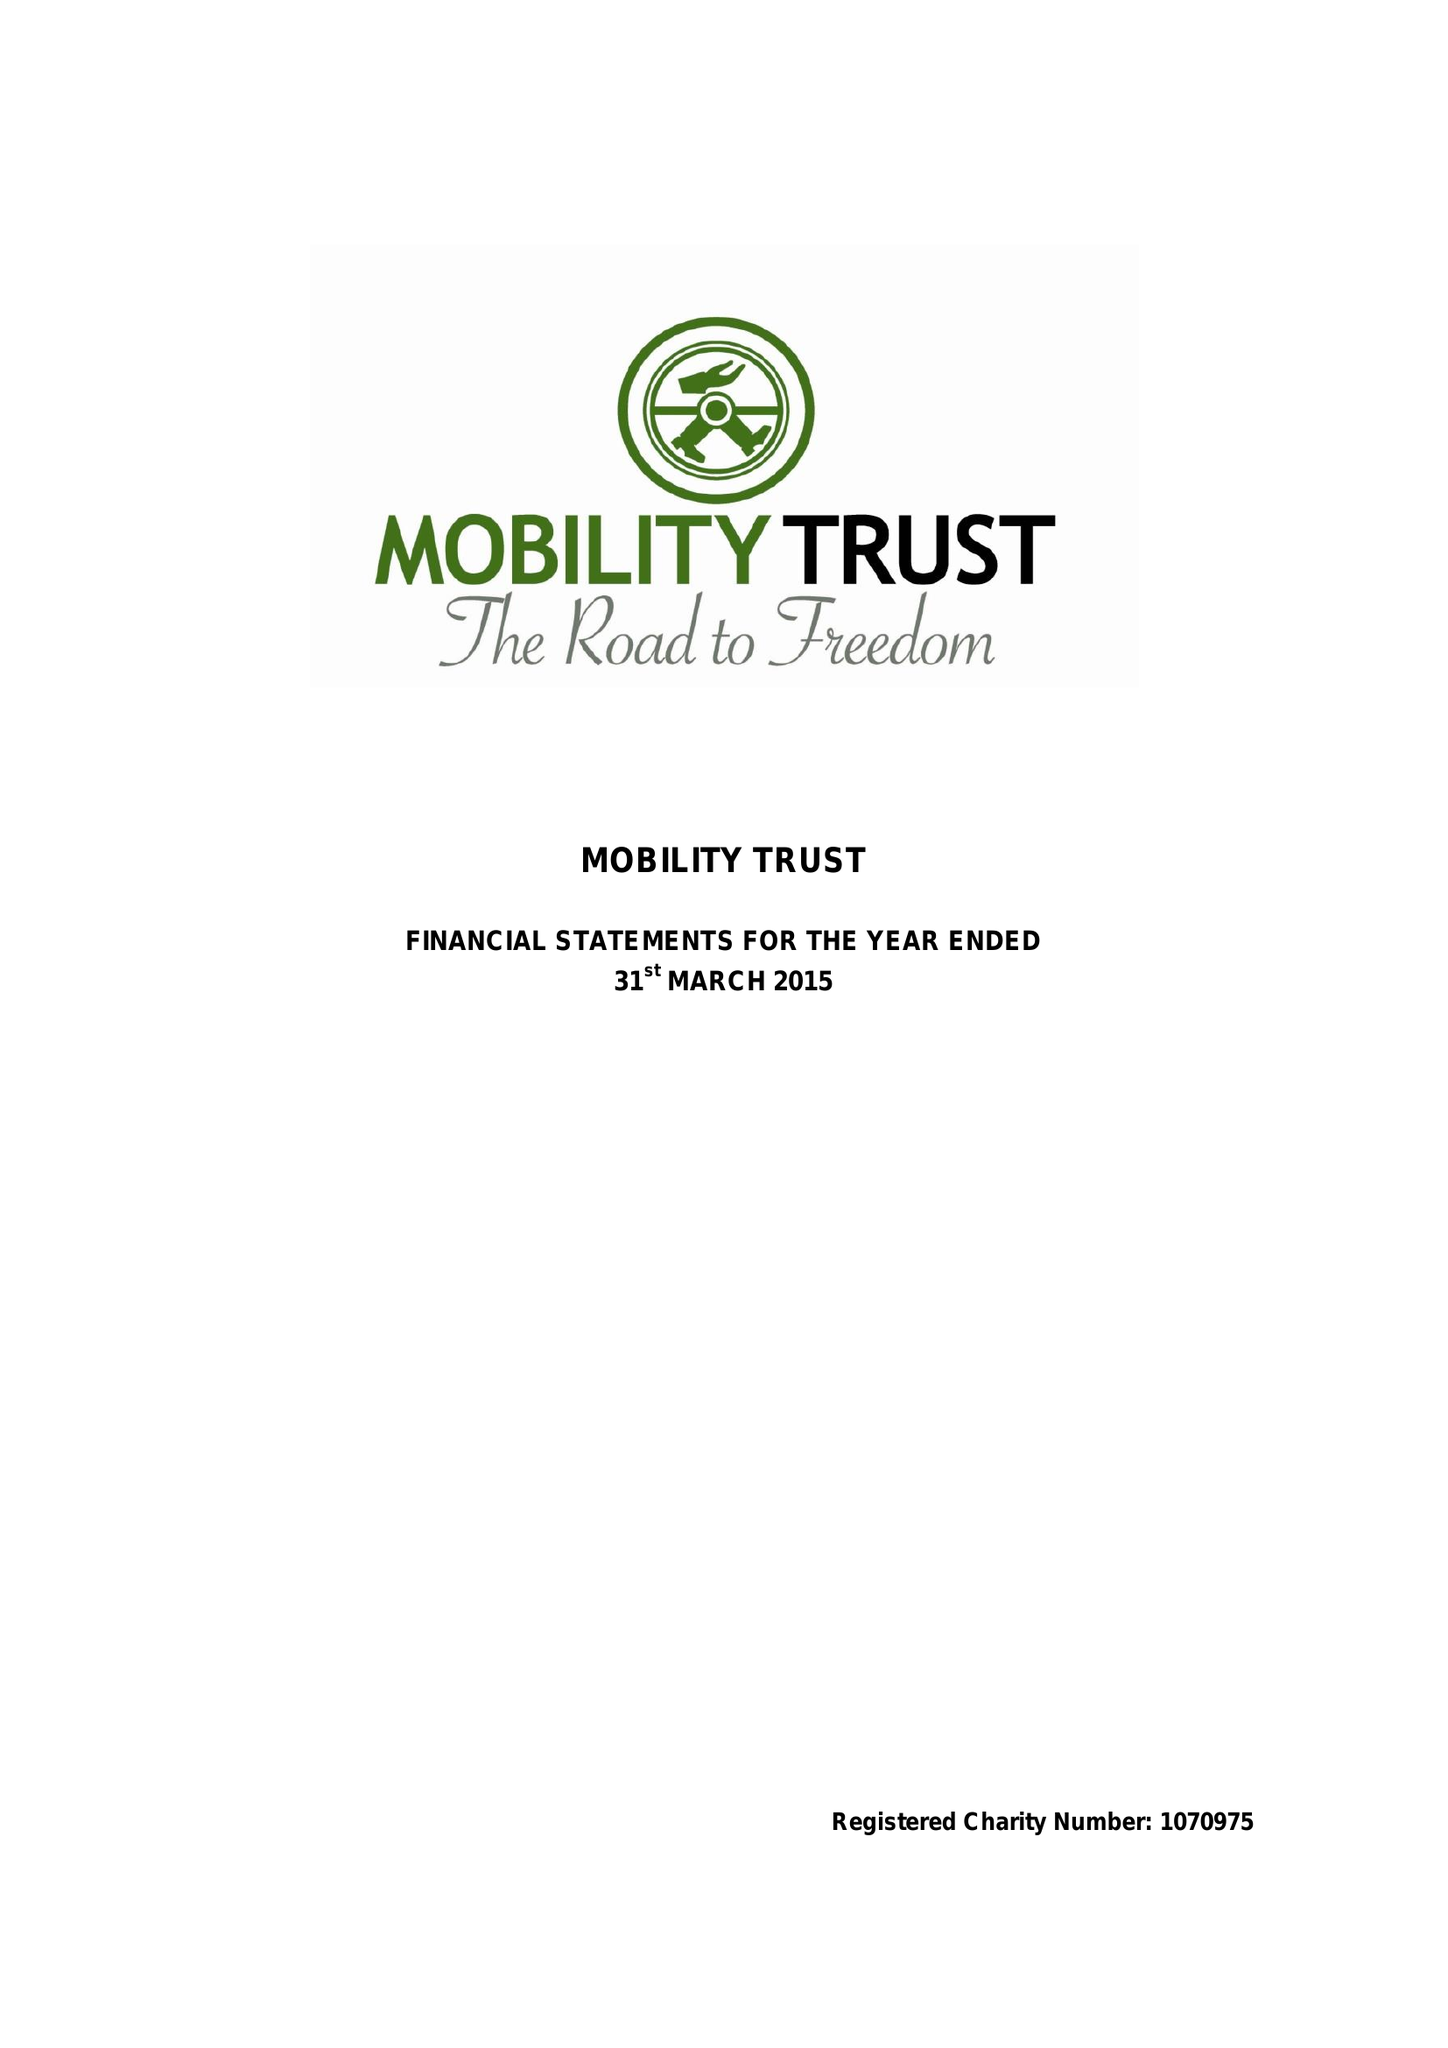What is the value for the charity_name?
Answer the question using a single word or phrase. Mobility Trust Ii 